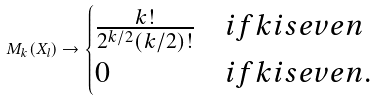Convert formula to latex. <formula><loc_0><loc_0><loc_500><loc_500>M _ { k } ( X _ { l } ) \to \begin{cases} \frac { k ! } { 2 ^ { k / 2 } ( k / 2 ) ! } & i f k i s e v e n \\ 0 & i f k i s e v e n . \end{cases}</formula> 